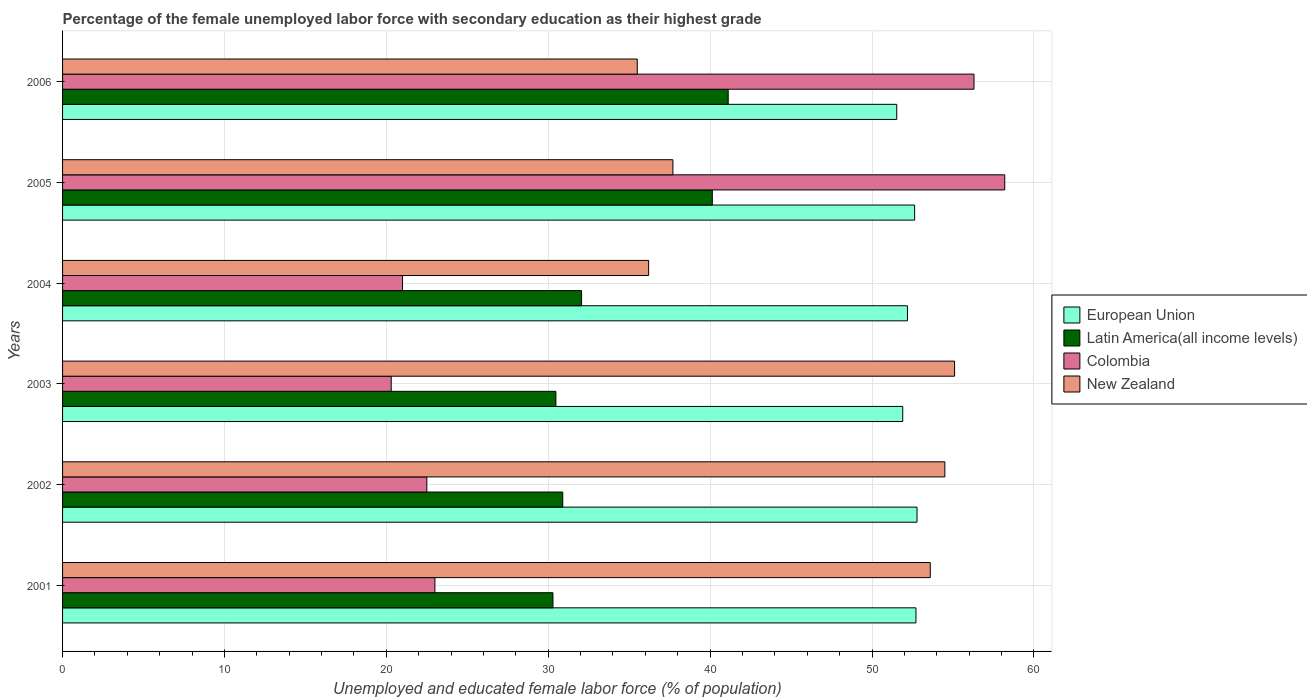How many different coloured bars are there?
Provide a succinct answer. 4. Are the number of bars on each tick of the Y-axis equal?
Your answer should be very brief. Yes. How many bars are there on the 3rd tick from the top?
Your answer should be very brief. 4. What is the label of the 5th group of bars from the top?
Keep it short and to the point. 2002. In how many cases, is the number of bars for a given year not equal to the number of legend labels?
Ensure brevity in your answer.  0. What is the percentage of the unemployed female labor force with secondary education in Colombia in 2005?
Keep it short and to the point. 58.2. Across all years, what is the maximum percentage of the unemployed female labor force with secondary education in European Union?
Your answer should be very brief. 52.78. Across all years, what is the minimum percentage of the unemployed female labor force with secondary education in Latin America(all income levels)?
Offer a terse response. 30.29. In which year was the percentage of the unemployed female labor force with secondary education in New Zealand maximum?
Provide a short and direct response. 2003. In which year was the percentage of the unemployed female labor force with secondary education in European Union minimum?
Your answer should be compact. 2006. What is the total percentage of the unemployed female labor force with secondary education in European Union in the graph?
Make the answer very short. 313.74. What is the difference between the percentage of the unemployed female labor force with secondary education in Latin America(all income levels) in 2001 and that in 2003?
Your answer should be compact. -0.18. What is the difference between the percentage of the unemployed female labor force with secondary education in Latin America(all income levels) in 2004 and the percentage of the unemployed female labor force with secondary education in New Zealand in 2001?
Provide a succinct answer. -21.54. What is the average percentage of the unemployed female labor force with secondary education in New Zealand per year?
Give a very brief answer. 45.43. In the year 2003, what is the difference between the percentage of the unemployed female labor force with secondary education in Colombia and percentage of the unemployed female labor force with secondary education in Latin America(all income levels)?
Your answer should be compact. -10.17. In how many years, is the percentage of the unemployed female labor force with secondary education in Colombia greater than 28 %?
Offer a very short reply. 2. What is the ratio of the percentage of the unemployed female labor force with secondary education in Colombia in 2003 to that in 2006?
Ensure brevity in your answer.  0.36. Is the percentage of the unemployed female labor force with secondary education in Colombia in 2002 less than that in 2006?
Your answer should be compact. Yes. What is the difference between the highest and the second highest percentage of the unemployed female labor force with secondary education in Latin America(all income levels)?
Make the answer very short. 0.98. What is the difference between the highest and the lowest percentage of the unemployed female labor force with secondary education in European Union?
Offer a terse response. 1.25. In how many years, is the percentage of the unemployed female labor force with secondary education in New Zealand greater than the average percentage of the unemployed female labor force with secondary education in New Zealand taken over all years?
Offer a terse response. 3. Is it the case that in every year, the sum of the percentage of the unemployed female labor force with secondary education in European Union and percentage of the unemployed female labor force with secondary education in New Zealand is greater than the sum of percentage of the unemployed female labor force with secondary education in Latin America(all income levels) and percentage of the unemployed female labor force with secondary education in Colombia?
Provide a succinct answer. Yes. What does the 1st bar from the top in 2004 represents?
Your answer should be compact. New Zealand. What does the 2nd bar from the bottom in 2004 represents?
Offer a very short reply. Latin America(all income levels). Is it the case that in every year, the sum of the percentage of the unemployed female labor force with secondary education in New Zealand and percentage of the unemployed female labor force with secondary education in Colombia is greater than the percentage of the unemployed female labor force with secondary education in European Union?
Your answer should be compact. Yes. How many bars are there?
Provide a succinct answer. 24. How many legend labels are there?
Offer a terse response. 4. What is the title of the graph?
Make the answer very short. Percentage of the female unemployed labor force with secondary education as their highest grade. Does "Greenland" appear as one of the legend labels in the graph?
Your answer should be compact. No. What is the label or title of the X-axis?
Offer a terse response. Unemployed and educated female labor force (% of population). What is the label or title of the Y-axis?
Keep it short and to the point. Years. What is the Unemployed and educated female labor force (% of population) in European Union in 2001?
Make the answer very short. 52.72. What is the Unemployed and educated female labor force (% of population) in Latin America(all income levels) in 2001?
Offer a very short reply. 30.29. What is the Unemployed and educated female labor force (% of population) of Colombia in 2001?
Provide a short and direct response. 23. What is the Unemployed and educated female labor force (% of population) in New Zealand in 2001?
Provide a short and direct response. 53.6. What is the Unemployed and educated female labor force (% of population) of European Union in 2002?
Give a very brief answer. 52.78. What is the Unemployed and educated female labor force (% of population) of Latin America(all income levels) in 2002?
Ensure brevity in your answer.  30.9. What is the Unemployed and educated female labor force (% of population) of New Zealand in 2002?
Give a very brief answer. 54.5. What is the Unemployed and educated female labor force (% of population) in European Union in 2003?
Keep it short and to the point. 51.9. What is the Unemployed and educated female labor force (% of population) of Latin America(all income levels) in 2003?
Offer a terse response. 30.47. What is the Unemployed and educated female labor force (% of population) in Colombia in 2003?
Give a very brief answer. 20.3. What is the Unemployed and educated female labor force (% of population) of New Zealand in 2003?
Your answer should be compact. 55.1. What is the Unemployed and educated female labor force (% of population) of European Union in 2004?
Ensure brevity in your answer.  52.19. What is the Unemployed and educated female labor force (% of population) in Latin America(all income levels) in 2004?
Your response must be concise. 32.06. What is the Unemployed and educated female labor force (% of population) of New Zealand in 2004?
Provide a succinct answer. 36.2. What is the Unemployed and educated female labor force (% of population) of European Union in 2005?
Your answer should be compact. 52.63. What is the Unemployed and educated female labor force (% of population) in Latin America(all income levels) in 2005?
Provide a short and direct response. 40.14. What is the Unemployed and educated female labor force (% of population) of Colombia in 2005?
Provide a succinct answer. 58.2. What is the Unemployed and educated female labor force (% of population) in New Zealand in 2005?
Offer a terse response. 37.7. What is the Unemployed and educated female labor force (% of population) in European Union in 2006?
Ensure brevity in your answer.  51.53. What is the Unemployed and educated female labor force (% of population) in Latin America(all income levels) in 2006?
Make the answer very short. 41.12. What is the Unemployed and educated female labor force (% of population) of Colombia in 2006?
Give a very brief answer. 56.3. What is the Unemployed and educated female labor force (% of population) of New Zealand in 2006?
Offer a very short reply. 35.5. Across all years, what is the maximum Unemployed and educated female labor force (% of population) in European Union?
Provide a succinct answer. 52.78. Across all years, what is the maximum Unemployed and educated female labor force (% of population) in Latin America(all income levels)?
Make the answer very short. 41.12. Across all years, what is the maximum Unemployed and educated female labor force (% of population) of Colombia?
Provide a succinct answer. 58.2. Across all years, what is the maximum Unemployed and educated female labor force (% of population) in New Zealand?
Offer a very short reply. 55.1. Across all years, what is the minimum Unemployed and educated female labor force (% of population) in European Union?
Make the answer very short. 51.53. Across all years, what is the minimum Unemployed and educated female labor force (% of population) of Latin America(all income levels)?
Offer a very short reply. 30.29. Across all years, what is the minimum Unemployed and educated female labor force (% of population) in Colombia?
Your answer should be very brief. 20.3. Across all years, what is the minimum Unemployed and educated female labor force (% of population) in New Zealand?
Offer a very short reply. 35.5. What is the total Unemployed and educated female labor force (% of population) of European Union in the graph?
Your response must be concise. 313.74. What is the total Unemployed and educated female labor force (% of population) of Latin America(all income levels) in the graph?
Provide a succinct answer. 204.97. What is the total Unemployed and educated female labor force (% of population) in Colombia in the graph?
Make the answer very short. 201.3. What is the total Unemployed and educated female labor force (% of population) of New Zealand in the graph?
Your response must be concise. 272.6. What is the difference between the Unemployed and educated female labor force (% of population) in European Union in 2001 and that in 2002?
Your answer should be very brief. -0.06. What is the difference between the Unemployed and educated female labor force (% of population) of Latin America(all income levels) in 2001 and that in 2002?
Give a very brief answer. -0.61. What is the difference between the Unemployed and educated female labor force (% of population) of New Zealand in 2001 and that in 2002?
Offer a very short reply. -0.9. What is the difference between the Unemployed and educated female labor force (% of population) of European Union in 2001 and that in 2003?
Make the answer very short. 0.82. What is the difference between the Unemployed and educated female labor force (% of population) of Latin America(all income levels) in 2001 and that in 2003?
Offer a very short reply. -0.18. What is the difference between the Unemployed and educated female labor force (% of population) in Colombia in 2001 and that in 2003?
Give a very brief answer. 2.7. What is the difference between the Unemployed and educated female labor force (% of population) in European Union in 2001 and that in 2004?
Provide a short and direct response. 0.53. What is the difference between the Unemployed and educated female labor force (% of population) of Latin America(all income levels) in 2001 and that in 2004?
Make the answer very short. -1.77. What is the difference between the Unemployed and educated female labor force (% of population) in Colombia in 2001 and that in 2004?
Keep it short and to the point. 2. What is the difference between the Unemployed and educated female labor force (% of population) in New Zealand in 2001 and that in 2004?
Keep it short and to the point. 17.4. What is the difference between the Unemployed and educated female labor force (% of population) in European Union in 2001 and that in 2005?
Offer a very short reply. 0.08. What is the difference between the Unemployed and educated female labor force (% of population) of Latin America(all income levels) in 2001 and that in 2005?
Your answer should be very brief. -9.85. What is the difference between the Unemployed and educated female labor force (% of population) of Colombia in 2001 and that in 2005?
Your response must be concise. -35.2. What is the difference between the Unemployed and educated female labor force (% of population) of New Zealand in 2001 and that in 2005?
Offer a terse response. 15.9. What is the difference between the Unemployed and educated female labor force (% of population) in European Union in 2001 and that in 2006?
Offer a terse response. 1.19. What is the difference between the Unemployed and educated female labor force (% of population) of Latin America(all income levels) in 2001 and that in 2006?
Offer a very short reply. -10.83. What is the difference between the Unemployed and educated female labor force (% of population) in Colombia in 2001 and that in 2006?
Provide a short and direct response. -33.3. What is the difference between the Unemployed and educated female labor force (% of population) in New Zealand in 2001 and that in 2006?
Your answer should be compact. 18.1. What is the difference between the Unemployed and educated female labor force (% of population) of European Union in 2002 and that in 2003?
Ensure brevity in your answer.  0.88. What is the difference between the Unemployed and educated female labor force (% of population) in Latin America(all income levels) in 2002 and that in 2003?
Your response must be concise. 0.42. What is the difference between the Unemployed and educated female labor force (% of population) in Colombia in 2002 and that in 2003?
Provide a short and direct response. 2.2. What is the difference between the Unemployed and educated female labor force (% of population) in European Union in 2002 and that in 2004?
Keep it short and to the point. 0.59. What is the difference between the Unemployed and educated female labor force (% of population) of Latin America(all income levels) in 2002 and that in 2004?
Provide a succinct answer. -1.16. What is the difference between the Unemployed and educated female labor force (% of population) of Colombia in 2002 and that in 2004?
Offer a terse response. 1.5. What is the difference between the Unemployed and educated female labor force (% of population) in New Zealand in 2002 and that in 2004?
Ensure brevity in your answer.  18.3. What is the difference between the Unemployed and educated female labor force (% of population) in European Union in 2002 and that in 2005?
Ensure brevity in your answer.  0.15. What is the difference between the Unemployed and educated female labor force (% of population) of Latin America(all income levels) in 2002 and that in 2005?
Make the answer very short. -9.24. What is the difference between the Unemployed and educated female labor force (% of population) in Colombia in 2002 and that in 2005?
Keep it short and to the point. -35.7. What is the difference between the Unemployed and educated female labor force (% of population) of European Union in 2002 and that in 2006?
Offer a terse response. 1.25. What is the difference between the Unemployed and educated female labor force (% of population) in Latin America(all income levels) in 2002 and that in 2006?
Offer a very short reply. -10.22. What is the difference between the Unemployed and educated female labor force (% of population) in Colombia in 2002 and that in 2006?
Ensure brevity in your answer.  -33.8. What is the difference between the Unemployed and educated female labor force (% of population) of New Zealand in 2002 and that in 2006?
Give a very brief answer. 19. What is the difference between the Unemployed and educated female labor force (% of population) of European Union in 2003 and that in 2004?
Give a very brief answer. -0.29. What is the difference between the Unemployed and educated female labor force (% of population) of Latin America(all income levels) in 2003 and that in 2004?
Give a very brief answer. -1.59. What is the difference between the Unemployed and educated female labor force (% of population) of Colombia in 2003 and that in 2004?
Provide a short and direct response. -0.7. What is the difference between the Unemployed and educated female labor force (% of population) in New Zealand in 2003 and that in 2004?
Provide a short and direct response. 18.9. What is the difference between the Unemployed and educated female labor force (% of population) in European Union in 2003 and that in 2005?
Keep it short and to the point. -0.74. What is the difference between the Unemployed and educated female labor force (% of population) in Latin America(all income levels) in 2003 and that in 2005?
Keep it short and to the point. -9.66. What is the difference between the Unemployed and educated female labor force (% of population) in Colombia in 2003 and that in 2005?
Make the answer very short. -37.9. What is the difference between the Unemployed and educated female labor force (% of population) of New Zealand in 2003 and that in 2005?
Make the answer very short. 17.4. What is the difference between the Unemployed and educated female labor force (% of population) in European Union in 2003 and that in 2006?
Your response must be concise. 0.37. What is the difference between the Unemployed and educated female labor force (% of population) of Latin America(all income levels) in 2003 and that in 2006?
Keep it short and to the point. -10.64. What is the difference between the Unemployed and educated female labor force (% of population) in Colombia in 2003 and that in 2006?
Give a very brief answer. -36. What is the difference between the Unemployed and educated female labor force (% of population) of New Zealand in 2003 and that in 2006?
Keep it short and to the point. 19.6. What is the difference between the Unemployed and educated female labor force (% of population) of European Union in 2004 and that in 2005?
Your answer should be compact. -0.44. What is the difference between the Unemployed and educated female labor force (% of population) in Latin America(all income levels) in 2004 and that in 2005?
Provide a succinct answer. -8.08. What is the difference between the Unemployed and educated female labor force (% of population) of Colombia in 2004 and that in 2005?
Offer a very short reply. -37.2. What is the difference between the Unemployed and educated female labor force (% of population) of European Union in 2004 and that in 2006?
Your response must be concise. 0.66. What is the difference between the Unemployed and educated female labor force (% of population) of Latin America(all income levels) in 2004 and that in 2006?
Offer a very short reply. -9.06. What is the difference between the Unemployed and educated female labor force (% of population) of Colombia in 2004 and that in 2006?
Ensure brevity in your answer.  -35.3. What is the difference between the Unemployed and educated female labor force (% of population) in New Zealand in 2004 and that in 2006?
Provide a short and direct response. 0.7. What is the difference between the Unemployed and educated female labor force (% of population) in European Union in 2005 and that in 2006?
Offer a terse response. 1.11. What is the difference between the Unemployed and educated female labor force (% of population) in Latin America(all income levels) in 2005 and that in 2006?
Keep it short and to the point. -0.98. What is the difference between the Unemployed and educated female labor force (% of population) in New Zealand in 2005 and that in 2006?
Keep it short and to the point. 2.2. What is the difference between the Unemployed and educated female labor force (% of population) of European Union in 2001 and the Unemployed and educated female labor force (% of population) of Latin America(all income levels) in 2002?
Provide a succinct answer. 21.82. What is the difference between the Unemployed and educated female labor force (% of population) in European Union in 2001 and the Unemployed and educated female labor force (% of population) in Colombia in 2002?
Give a very brief answer. 30.22. What is the difference between the Unemployed and educated female labor force (% of population) in European Union in 2001 and the Unemployed and educated female labor force (% of population) in New Zealand in 2002?
Keep it short and to the point. -1.78. What is the difference between the Unemployed and educated female labor force (% of population) of Latin America(all income levels) in 2001 and the Unemployed and educated female labor force (% of population) of Colombia in 2002?
Offer a very short reply. 7.79. What is the difference between the Unemployed and educated female labor force (% of population) of Latin America(all income levels) in 2001 and the Unemployed and educated female labor force (% of population) of New Zealand in 2002?
Offer a terse response. -24.21. What is the difference between the Unemployed and educated female labor force (% of population) in Colombia in 2001 and the Unemployed and educated female labor force (% of population) in New Zealand in 2002?
Make the answer very short. -31.5. What is the difference between the Unemployed and educated female labor force (% of population) of European Union in 2001 and the Unemployed and educated female labor force (% of population) of Latin America(all income levels) in 2003?
Provide a short and direct response. 22.24. What is the difference between the Unemployed and educated female labor force (% of population) of European Union in 2001 and the Unemployed and educated female labor force (% of population) of Colombia in 2003?
Your answer should be compact. 32.42. What is the difference between the Unemployed and educated female labor force (% of population) in European Union in 2001 and the Unemployed and educated female labor force (% of population) in New Zealand in 2003?
Give a very brief answer. -2.38. What is the difference between the Unemployed and educated female labor force (% of population) of Latin America(all income levels) in 2001 and the Unemployed and educated female labor force (% of population) of Colombia in 2003?
Your response must be concise. 9.99. What is the difference between the Unemployed and educated female labor force (% of population) in Latin America(all income levels) in 2001 and the Unemployed and educated female labor force (% of population) in New Zealand in 2003?
Provide a short and direct response. -24.81. What is the difference between the Unemployed and educated female labor force (% of population) in Colombia in 2001 and the Unemployed and educated female labor force (% of population) in New Zealand in 2003?
Ensure brevity in your answer.  -32.1. What is the difference between the Unemployed and educated female labor force (% of population) of European Union in 2001 and the Unemployed and educated female labor force (% of population) of Latin America(all income levels) in 2004?
Give a very brief answer. 20.66. What is the difference between the Unemployed and educated female labor force (% of population) of European Union in 2001 and the Unemployed and educated female labor force (% of population) of Colombia in 2004?
Keep it short and to the point. 31.72. What is the difference between the Unemployed and educated female labor force (% of population) of European Union in 2001 and the Unemployed and educated female labor force (% of population) of New Zealand in 2004?
Offer a very short reply. 16.52. What is the difference between the Unemployed and educated female labor force (% of population) in Latin America(all income levels) in 2001 and the Unemployed and educated female labor force (% of population) in Colombia in 2004?
Your answer should be compact. 9.29. What is the difference between the Unemployed and educated female labor force (% of population) in Latin America(all income levels) in 2001 and the Unemployed and educated female labor force (% of population) in New Zealand in 2004?
Ensure brevity in your answer.  -5.91. What is the difference between the Unemployed and educated female labor force (% of population) of European Union in 2001 and the Unemployed and educated female labor force (% of population) of Latin America(all income levels) in 2005?
Your answer should be compact. 12.58. What is the difference between the Unemployed and educated female labor force (% of population) of European Union in 2001 and the Unemployed and educated female labor force (% of population) of Colombia in 2005?
Provide a short and direct response. -5.48. What is the difference between the Unemployed and educated female labor force (% of population) of European Union in 2001 and the Unemployed and educated female labor force (% of population) of New Zealand in 2005?
Offer a very short reply. 15.02. What is the difference between the Unemployed and educated female labor force (% of population) of Latin America(all income levels) in 2001 and the Unemployed and educated female labor force (% of population) of Colombia in 2005?
Provide a short and direct response. -27.91. What is the difference between the Unemployed and educated female labor force (% of population) of Latin America(all income levels) in 2001 and the Unemployed and educated female labor force (% of population) of New Zealand in 2005?
Your response must be concise. -7.41. What is the difference between the Unemployed and educated female labor force (% of population) of Colombia in 2001 and the Unemployed and educated female labor force (% of population) of New Zealand in 2005?
Provide a short and direct response. -14.7. What is the difference between the Unemployed and educated female labor force (% of population) of European Union in 2001 and the Unemployed and educated female labor force (% of population) of Latin America(all income levels) in 2006?
Offer a terse response. 11.6. What is the difference between the Unemployed and educated female labor force (% of population) of European Union in 2001 and the Unemployed and educated female labor force (% of population) of Colombia in 2006?
Provide a short and direct response. -3.58. What is the difference between the Unemployed and educated female labor force (% of population) in European Union in 2001 and the Unemployed and educated female labor force (% of population) in New Zealand in 2006?
Keep it short and to the point. 17.22. What is the difference between the Unemployed and educated female labor force (% of population) of Latin America(all income levels) in 2001 and the Unemployed and educated female labor force (% of population) of Colombia in 2006?
Offer a terse response. -26.01. What is the difference between the Unemployed and educated female labor force (% of population) of Latin America(all income levels) in 2001 and the Unemployed and educated female labor force (% of population) of New Zealand in 2006?
Make the answer very short. -5.21. What is the difference between the Unemployed and educated female labor force (% of population) of Colombia in 2001 and the Unemployed and educated female labor force (% of population) of New Zealand in 2006?
Your response must be concise. -12.5. What is the difference between the Unemployed and educated female labor force (% of population) in European Union in 2002 and the Unemployed and educated female labor force (% of population) in Latin America(all income levels) in 2003?
Your answer should be compact. 22.31. What is the difference between the Unemployed and educated female labor force (% of population) of European Union in 2002 and the Unemployed and educated female labor force (% of population) of Colombia in 2003?
Offer a terse response. 32.48. What is the difference between the Unemployed and educated female labor force (% of population) in European Union in 2002 and the Unemployed and educated female labor force (% of population) in New Zealand in 2003?
Offer a terse response. -2.32. What is the difference between the Unemployed and educated female labor force (% of population) of Latin America(all income levels) in 2002 and the Unemployed and educated female labor force (% of population) of Colombia in 2003?
Make the answer very short. 10.6. What is the difference between the Unemployed and educated female labor force (% of population) of Latin America(all income levels) in 2002 and the Unemployed and educated female labor force (% of population) of New Zealand in 2003?
Offer a very short reply. -24.2. What is the difference between the Unemployed and educated female labor force (% of population) in Colombia in 2002 and the Unemployed and educated female labor force (% of population) in New Zealand in 2003?
Your answer should be compact. -32.6. What is the difference between the Unemployed and educated female labor force (% of population) of European Union in 2002 and the Unemployed and educated female labor force (% of population) of Latin America(all income levels) in 2004?
Offer a terse response. 20.72. What is the difference between the Unemployed and educated female labor force (% of population) in European Union in 2002 and the Unemployed and educated female labor force (% of population) in Colombia in 2004?
Your answer should be compact. 31.78. What is the difference between the Unemployed and educated female labor force (% of population) of European Union in 2002 and the Unemployed and educated female labor force (% of population) of New Zealand in 2004?
Give a very brief answer. 16.58. What is the difference between the Unemployed and educated female labor force (% of population) in Latin America(all income levels) in 2002 and the Unemployed and educated female labor force (% of population) in Colombia in 2004?
Your answer should be very brief. 9.9. What is the difference between the Unemployed and educated female labor force (% of population) in Latin America(all income levels) in 2002 and the Unemployed and educated female labor force (% of population) in New Zealand in 2004?
Your answer should be very brief. -5.3. What is the difference between the Unemployed and educated female labor force (% of population) in Colombia in 2002 and the Unemployed and educated female labor force (% of population) in New Zealand in 2004?
Your answer should be very brief. -13.7. What is the difference between the Unemployed and educated female labor force (% of population) of European Union in 2002 and the Unemployed and educated female labor force (% of population) of Latin America(all income levels) in 2005?
Your response must be concise. 12.64. What is the difference between the Unemployed and educated female labor force (% of population) of European Union in 2002 and the Unemployed and educated female labor force (% of population) of Colombia in 2005?
Your answer should be very brief. -5.42. What is the difference between the Unemployed and educated female labor force (% of population) in European Union in 2002 and the Unemployed and educated female labor force (% of population) in New Zealand in 2005?
Your answer should be compact. 15.08. What is the difference between the Unemployed and educated female labor force (% of population) in Latin America(all income levels) in 2002 and the Unemployed and educated female labor force (% of population) in Colombia in 2005?
Provide a succinct answer. -27.3. What is the difference between the Unemployed and educated female labor force (% of population) of Latin America(all income levels) in 2002 and the Unemployed and educated female labor force (% of population) of New Zealand in 2005?
Make the answer very short. -6.8. What is the difference between the Unemployed and educated female labor force (% of population) in Colombia in 2002 and the Unemployed and educated female labor force (% of population) in New Zealand in 2005?
Provide a short and direct response. -15.2. What is the difference between the Unemployed and educated female labor force (% of population) in European Union in 2002 and the Unemployed and educated female labor force (% of population) in Latin America(all income levels) in 2006?
Your response must be concise. 11.66. What is the difference between the Unemployed and educated female labor force (% of population) of European Union in 2002 and the Unemployed and educated female labor force (% of population) of Colombia in 2006?
Your answer should be compact. -3.52. What is the difference between the Unemployed and educated female labor force (% of population) of European Union in 2002 and the Unemployed and educated female labor force (% of population) of New Zealand in 2006?
Your answer should be very brief. 17.28. What is the difference between the Unemployed and educated female labor force (% of population) of Latin America(all income levels) in 2002 and the Unemployed and educated female labor force (% of population) of Colombia in 2006?
Provide a succinct answer. -25.4. What is the difference between the Unemployed and educated female labor force (% of population) of Latin America(all income levels) in 2002 and the Unemployed and educated female labor force (% of population) of New Zealand in 2006?
Your response must be concise. -4.6. What is the difference between the Unemployed and educated female labor force (% of population) in European Union in 2003 and the Unemployed and educated female labor force (% of population) in Latin America(all income levels) in 2004?
Offer a very short reply. 19.84. What is the difference between the Unemployed and educated female labor force (% of population) in European Union in 2003 and the Unemployed and educated female labor force (% of population) in Colombia in 2004?
Give a very brief answer. 30.9. What is the difference between the Unemployed and educated female labor force (% of population) in European Union in 2003 and the Unemployed and educated female labor force (% of population) in New Zealand in 2004?
Offer a very short reply. 15.7. What is the difference between the Unemployed and educated female labor force (% of population) of Latin America(all income levels) in 2003 and the Unemployed and educated female labor force (% of population) of Colombia in 2004?
Your response must be concise. 9.47. What is the difference between the Unemployed and educated female labor force (% of population) in Latin America(all income levels) in 2003 and the Unemployed and educated female labor force (% of population) in New Zealand in 2004?
Provide a short and direct response. -5.73. What is the difference between the Unemployed and educated female labor force (% of population) in Colombia in 2003 and the Unemployed and educated female labor force (% of population) in New Zealand in 2004?
Offer a terse response. -15.9. What is the difference between the Unemployed and educated female labor force (% of population) in European Union in 2003 and the Unemployed and educated female labor force (% of population) in Latin America(all income levels) in 2005?
Your answer should be compact. 11.76. What is the difference between the Unemployed and educated female labor force (% of population) in European Union in 2003 and the Unemployed and educated female labor force (% of population) in Colombia in 2005?
Offer a terse response. -6.3. What is the difference between the Unemployed and educated female labor force (% of population) of European Union in 2003 and the Unemployed and educated female labor force (% of population) of New Zealand in 2005?
Offer a terse response. 14.2. What is the difference between the Unemployed and educated female labor force (% of population) of Latin America(all income levels) in 2003 and the Unemployed and educated female labor force (% of population) of Colombia in 2005?
Keep it short and to the point. -27.73. What is the difference between the Unemployed and educated female labor force (% of population) in Latin America(all income levels) in 2003 and the Unemployed and educated female labor force (% of population) in New Zealand in 2005?
Ensure brevity in your answer.  -7.23. What is the difference between the Unemployed and educated female labor force (% of population) of Colombia in 2003 and the Unemployed and educated female labor force (% of population) of New Zealand in 2005?
Ensure brevity in your answer.  -17.4. What is the difference between the Unemployed and educated female labor force (% of population) of European Union in 2003 and the Unemployed and educated female labor force (% of population) of Latin America(all income levels) in 2006?
Ensure brevity in your answer.  10.78. What is the difference between the Unemployed and educated female labor force (% of population) of European Union in 2003 and the Unemployed and educated female labor force (% of population) of Colombia in 2006?
Keep it short and to the point. -4.4. What is the difference between the Unemployed and educated female labor force (% of population) of European Union in 2003 and the Unemployed and educated female labor force (% of population) of New Zealand in 2006?
Your answer should be very brief. 16.4. What is the difference between the Unemployed and educated female labor force (% of population) in Latin America(all income levels) in 2003 and the Unemployed and educated female labor force (% of population) in Colombia in 2006?
Offer a very short reply. -25.83. What is the difference between the Unemployed and educated female labor force (% of population) of Latin America(all income levels) in 2003 and the Unemployed and educated female labor force (% of population) of New Zealand in 2006?
Keep it short and to the point. -5.03. What is the difference between the Unemployed and educated female labor force (% of population) in Colombia in 2003 and the Unemployed and educated female labor force (% of population) in New Zealand in 2006?
Offer a very short reply. -15.2. What is the difference between the Unemployed and educated female labor force (% of population) of European Union in 2004 and the Unemployed and educated female labor force (% of population) of Latin America(all income levels) in 2005?
Provide a short and direct response. 12.05. What is the difference between the Unemployed and educated female labor force (% of population) of European Union in 2004 and the Unemployed and educated female labor force (% of population) of Colombia in 2005?
Make the answer very short. -6.01. What is the difference between the Unemployed and educated female labor force (% of population) in European Union in 2004 and the Unemployed and educated female labor force (% of population) in New Zealand in 2005?
Give a very brief answer. 14.49. What is the difference between the Unemployed and educated female labor force (% of population) of Latin America(all income levels) in 2004 and the Unemployed and educated female labor force (% of population) of Colombia in 2005?
Offer a terse response. -26.14. What is the difference between the Unemployed and educated female labor force (% of population) in Latin America(all income levels) in 2004 and the Unemployed and educated female labor force (% of population) in New Zealand in 2005?
Your answer should be very brief. -5.64. What is the difference between the Unemployed and educated female labor force (% of population) of Colombia in 2004 and the Unemployed and educated female labor force (% of population) of New Zealand in 2005?
Your answer should be very brief. -16.7. What is the difference between the Unemployed and educated female labor force (% of population) of European Union in 2004 and the Unemployed and educated female labor force (% of population) of Latin America(all income levels) in 2006?
Offer a terse response. 11.07. What is the difference between the Unemployed and educated female labor force (% of population) in European Union in 2004 and the Unemployed and educated female labor force (% of population) in Colombia in 2006?
Give a very brief answer. -4.11. What is the difference between the Unemployed and educated female labor force (% of population) in European Union in 2004 and the Unemployed and educated female labor force (% of population) in New Zealand in 2006?
Ensure brevity in your answer.  16.69. What is the difference between the Unemployed and educated female labor force (% of population) in Latin America(all income levels) in 2004 and the Unemployed and educated female labor force (% of population) in Colombia in 2006?
Provide a short and direct response. -24.24. What is the difference between the Unemployed and educated female labor force (% of population) of Latin America(all income levels) in 2004 and the Unemployed and educated female labor force (% of population) of New Zealand in 2006?
Your answer should be very brief. -3.44. What is the difference between the Unemployed and educated female labor force (% of population) in European Union in 2005 and the Unemployed and educated female labor force (% of population) in Latin America(all income levels) in 2006?
Offer a very short reply. 11.52. What is the difference between the Unemployed and educated female labor force (% of population) of European Union in 2005 and the Unemployed and educated female labor force (% of population) of Colombia in 2006?
Your answer should be compact. -3.67. What is the difference between the Unemployed and educated female labor force (% of population) in European Union in 2005 and the Unemployed and educated female labor force (% of population) in New Zealand in 2006?
Offer a terse response. 17.13. What is the difference between the Unemployed and educated female labor force (% of population) of Latin America(all income levels) in 2005 and the Unemployed and educated female labor force (% of population) of Colombia in 2006?
Your answer should be compact. -16.16. What is the difference between the Unemployed and educated female labor force (% of population) of Latin America(all income levels) in 2005 and the Unemployed and educated female labor force (% of population) of New Zealand in 2006?
Your answer should be compact. 4.64. What is the difference between the Unemployed and educated female labor force (% of population) of Colombia in 2005 and the Unemployed and educated female labor force (% of population) of New Zealand in 2006?
Offer a terse response. 22.7. What is the average Unemployed and educated female labor force (% of population) in European Union per year?
Ensure brevity in your answer.  52.29. What is the average Unemployed and educated female labor force (% of population) in Latin America(all income levels) per year?
Give a very brief answer. 34.16. What is the average Unemployed and educated female labor force (% of population) of Colombia per year?
Offer a very short reply. 33.55. What is the average Unemployed and educated female labor force (% of population) in New Zealand per year?
Offer a terse response. 45.43. In the year 2001, what is the difference between the Unemployed and educated female labor force (% of population) in European Union and Unemployed and educated female labor force (% of population) in Latin America(all income levels)?
Offer a terse response. 22.42. In the year 2001, what is the difference between the Unemployed and educated female labor force (% of population) in European Union and Unemployed and educated female labor force (% of population) in Colombia?
Make the answer very short. 29.72. In the year 2001, what is the difference between the Unemployed and educated female labor force (% of population) in European Union and Unemployed and educated female labor force (% of population) in New Zealand?
Provide a short and direct response. -0.88. In the year 2001, what is the difference between the Unemployed and educated female labor force (% of population) of Latin America(all income levels) and Unemployed and educated female labor force (% of population) of Colombia?
Keep it short and to the point. 7.29. In the year 2001, what is the difference between the Unemployed and educated female labor force (% of population) of Latin America(all income levels) and Unemployed and educated female labor force (% of population) of New Zealand?
Provide a short and direct response. -23.31. In the year 2001, what is the difference between the Unemployed and educated female labor force (% of population) in Colombia and Unemployed and educated female labor force (% of population) in New Zealand?
Offer a terse response. -30.6. In the year 2002, what is the difference between the Unemployed and educated female labor force (% of population) in European Union and Unemployed and educated female labor force (% of population) in Latin America(all income levels)?
Make the answer very short. 21.88. In the year 2002, what is the difference between the Unemployed and educated female labor force (% of population) of European Union and Unemployed and educated female labor force (% of population) of Colombia?
Offer a very short reply. 30.28. In the year 2002, what is the difference between the Unemployed and educated female labor force (% of population) of European Union and Unemployed and educated female labor force (% of population) of New Zealand?
Offer a terse response. -1.72. In the year 2002, what is the difference between the Unemployed and educated female labor force (% of population) in Latin America(all income levels) and Unemployed and educated female labor force (% of population) in Colombia?
Give a very brief answer. 8.4. In the year 2002, what is the difference between the Unemployed and educated female labor force (% of population) of Latin America(all income levels) and Unemployed and educated female labor force (% of population) of New Zealand?
Your answer should be very brief. -23.6. In the year 2002, what is the difference between the Unemployed and educated female labor force (% of population) of Colombia and Unemployed and educated female labor force (% of population) of New Zealand?
Offer a terse response. -32. In the year 2003, what is the difference between the Unemployed and educated female labor force (% of population) of European Union and Unemployed and educated female labor force (% of population) of Latin America(all income levels)?
Ensure brevity in your answer.  21.42. In the year 2003, what is the difference between the Unemployed and educated female labor force (% of population) of European Union and Unemployed and educated female labor force (% of population) of Colombia?
Keep it short and to the point. 31.6. In the year 2003, what is the difference between the Unemployed and educated female labor force (% of population) of European Union and Unemployed and educated female labor force (% of population) of New Zealand?
Your answer should be very brief. -3.2. In the year 2003, what is the difference between the Unemployed and educated female labor force (% of population) of Latin America(all income levels) and Unemployed and educated female labor force (% of population) of Colombia?
Give a very brief answer. 10.17. In the year 2003, what is the difference between the Unemployed and educated female labor force (% of population) in Latin America(all income levels) and Unemployed and educated female labor force (% of population) in New Zealand?
Offer a very short reply. -24.63. In the year 2003, what is the difference between the Unemployed and educated female labor force (% of population) of Colombia and Unemployed and educated female labor force (% of population) of New Zealand?
Provide a succinct answer. -34.8. In the year 2004, what is the difference between the Unemployed and educated female labor force (% of population) of European Union and Unemployed and educated female labor force (% of population) of Latin America(all income levels)?
Offer a terse response. 20.13. In the year 2004, what is the difference between the Unemployed and educated female labor force (% of population) of European Union and Unemployed and educated female labor force (% of population) of Colombia?
Your answer should be very brief. 31.19. In the year 2004, what is the difference between the Unemployed and educated female labor force (% of population) of European Union and Unemployed and educated female labor force (% of population) of New Zealand?
Make the answer very short. 15.99. In the year 2004, what is the difference between the Unemployed and educated female labor force (% of population) in Latin America(all income levels) and Unemployed and educated female labor force (% of population) in Colombia?
Keep it short and to the point. 11.06. In the year 2004, what is the difference between the Unemployed and educated female labor force (% of population) in Latin America(all income levels) and Unemployed and educated female labor force (% of population) in New Zealand?
Provide a short and direct response. -4.14. In the year 2004, what is the difference between the Unemployed and educated female labor force (% of population) in Colombia and Unemployed and educated female labor force (% of population) in New Zealand?
Your response must be concise. -15.2. In the year 2005, what is the difference between the Unemployed and educated female labor force (% of population) of European Union and Unemployed and educated female labor force (% of population) of Latin America(all income levels)?
Provide a succinct answer. 12.5. In the year 2005, what is the difference between the Unemployed and educated female labor force (% of population) in European Union and Unemployed and educated female labor force (% of population) in Colombia?
Provide a succinct answer. -5.57. In the year 2005, what is the difference between the Unemployed and educated female labor force (% of population) of European Union and Unemployed and educated female labor force (% of population) of New Zealand?
Make the answer very short. 14.93. In the year 2005, what is the difference between the Unemployed and educated female labor force (% of population) in Latin America(all income levels) and Unemployed and educated female labor force (% of population) in Colombia?
Provide a short and direct response. -18.06. In the year 2005, what is the difference between the Unemployed and educated female labor force (% of population) in Latin America(all income levels) and Unemployed and educated female labor force (% of population) in New Zealand?
Provide a succinct answer. 2.44. In the year 2005, what is the difference between the Unemployed and educated female labor force (% of population) of Colombia and Unemployed and educated female labor force (% of population) of New Zealand?
Provide a short and direct response. 20.5. In the year 2006, what is the difference between the Unemployed and educated female labor force (% of population) in European Union and Unemployed and educated female labor force (% of population) in Latin America(all income levels)?
Offer a terse response. 10.41. In the year 2006, what is the difference between the Unemployed and educated female labor force (% of population) of European Union and Unemployed and educated female labor force (% of population) of Colombia?
Your response must be concise. -4.77. In the year 2006, what is the difference between the Unemployed and educated female labor force (% of population) in European Union and Unemployed and educated female labor force (% of population) in New Zealand?
Keep it short and to the point. 16.03. In the year 2006, what is the difference between the Unemployed and educated female labor force (% of population) of Latin America(all income levels) and Unemployed and educated female labor force (% of population) of Colombia?
Give a very brief answer. -15.18. In the year 2006, what is the difference between the Unemployed and educated female labor force (% of population) in Latin America(all income levels) and Unemployed and educated female labor force (% of population) in New Zealand?
Your response must be concise. 5.62. In the year 2006, what is the difference between the Unemployed and educated female labor force (% of population) of Colombia and Unemployed and educated female labor force (% of population) of New Zealand?
Give a very brief answer. 20.8. What is the ratio of the Unemployed and educated female labor force (% of population) of European Union in 2001 to that in 2002?
Ensure brevity in your answer.  1. What is the ratio of the Unemployed and educated female labor force (% of population) of Latin America(all income levels) in 2001 to that in 2002?
Ensure brevity in your answer.  0.98. What is the ratio of the Unemployed and educated female labor force (% of population) of Colombia in 2001 to that in 2002?
Provide a short and direct response. 1.02. What is the ratio of the Unemployed and educated female labor force (% of population) of New Zealand in 2001 to that in 2002?
Ensure brevity in your answer.  0.98. What is the ratio of the Unemployed and educated female labor force (% of population) of European Union in 2001 to that in 2003?
Ensure brevity in your answer.  1.02. What is the ratio of the Unemployed and educated female labor force (% of population) in Colombia in 2001 to that in 2003?
Your answer should be very brief. 1.13. What is the ratio of the Unemployed and educated female labor force (% of population) of New Zealand in 2001 to that in 2003?
Your response must be concise. 0.97. What is the ratio of the Unemployed and educated female labor force (% of population) of European Union in 2001 to that in 2004?
Keep it short and to the point. 1.01. What is the ratio of the Unemployed and educated female labor force (% of population) in Latin America(all income levels) in 2001 to that in 2004?
Your response must be concise. 0.94. What is the ratio of the Unemployed and educated female labor force (% of population) in Colombia in 2001 to that in 2004?
Make the answer very short. 1.1. What is the ratio of the Unemployed and educated female labor force (% of population) in New Zealand in 2001 to that in 2004?
Offer a very short reply. 1.48. What is the ratio of the Unemployed and educated female labor force (% of population) of European Union in 2001 to that in 2005?
Ensure brevity in your answer.  1. What is the ratio of the Unemployed and educated female labor force (% of population) in Latin America(all income levels) in 2001 to that in 2005?
Provide a short and direct response. 0.75. What is the ratio of the Unemployed and educated female labor force (% of population) of Colombia in 2001 to that in 2005?
Offer a terse response. 0.4. What is the ratio of the Unemployed and educated female labor force (% of population) of New Zealand in 2001 to that in 2005?
Keep it short and to the point. 1.42. What is the ratio of the Unemployed and educated female labor force (% of population) in European Union in 2001 to that in 2006?
Provide a short and direct response. 1.02. What is the ratio of the Unemployed and educated female labor force (% of population) in Latin America(all income levels) in 2001 to that in 2006?
Provide a succinct answer. 0.74. What is the ratio of the Unemployed and educated female labor force (% of population) of Colombia in 2001 to that in 2006?
Provide a short and direct response. 0.41. What is the ratio of the Unemployed and educated female labor force (% of population) in New Zealand in 2001 to that in 2006?
Keep it short and to the point. 1.51. What is the ratio of the Unemployed and educated female labor force (% of population) in Latin America(all income levels) in 2002 to that in 2003?
Give a very brief answer. 1.01. What is the ratio of the Unemployed and educated female labor force (% of population) in Colombia in 2002 to that in 2003?
Give a very brief answer. 1.11. What is the ratio of the Unemployed and educated female labor force (% of population) of New Zealand in 2002 to that in 2003?
Keep it short and to the point. 0.99. What is the ratio of the Unemployed and educated female labor force (% of population) of European Union in 2002 to that in 2004?
Give a very brief answer. 1.01. What is the ratio of the Unemployed and educated female labor force (% of population) in Latin America(all income levels) in 2002 to that in 2004?
Your response must be concise. 0.96. What is the ratio of the Unemployed and educated female labor force (% of population) of Colombia in 2002 to that in 2004?
Offer a terse response. 1.07. What is the ratio of the Unemployed and educated female labor force (% of population) in New Zealand in 2002 to that in 2004?
Ensure brevity in your answer.  1.51. What is the ratio of the Unemployed and educated female labor force (% of population) of Latin America(all income levels) in 2002 to that in 2005?
Offer a terse response. 0.77. What is the ratio of the Unemployed and educated female labor force (% of population) in Colombia in 2002 to that in 2005?
Your answer should be compact. 0.39. What is the ratio of the Unemployed and educated female labor force (% of population) of New Zealand in 2002 to that in 2005?
Provide a short and direct response. 1.45. What is the ratio of the Unemployed and educated female labor force (% of population) of European Union in 2002 to that in 2006?
Your answer should be very brief. 1.02. What is the ratio of the Unemployed and educated female labor force (% of population) in Latin America(all income levels) in 2002 to that in 2006?
Your answer should be very brief. 0.75. What is the ratio of the Unemployed and educated female labor force (% of population) of Colombia in 2002 to that in 2006?
Offer a terse response. 0.4. What is the ratio of the Unemployed and educated female labor force (% of population) in New Zealand in 2002 to that in 2006?
Offer a terse response. 1.54. What is the ratio of the Unemployed and educated female labor force (% of population) in Latin America(all income levels) in 2003 to that in 2004?
Give a very brief answer. 0.95. What is the ratio of the Unemployed and educated female labor force (% of population) of Colombia in 2003 to that in 2004?
Your answer should be compact. 0.97. What is the ratio of the Unemployed and educated female labor force (% of population) in New Zealand in 2003 to that in 2004?
Provide a succinct answer. 1.52. What is the ratio of the Unemployed and educated female labor force (% of population) in European Union in 2003 to that in 2005?
Ensure brevity in your answer.  0.99. What is the ratio of the Unemployed and educated female labor force (% of population) of Latin America(all income levels) in 2003 to that in 2005?
Offer a terse response. 0.76. What is the ratio of the Unemployed and educated female labor force (% of population) in Colombia in 2003 to that in 2005?
Make the answer very short. 0.35. What is the ratio of the Unemployed and educated female labor force (% of population) in New Zealand in 2003 to that in 2005?
Offer a terse response. 1.46. What is the ratio of the Unemployed and educated female labor force (% of population) of Latin America(all income levels) in 2003 to that in 2006?
Provide a short and direct response. 0.74. What is the ratio of the Unemployed and educated female labor force (% of population) in Colombia in 2003 to that in 2006?
Offer a very short reply. 0.36. What is the ratio of the Unemployed and educated female labor force (% of population) in New Zealand in 2003 to that in 2006?
Offer a very short reply. 1.55. What is the ratio of the Unemployed and educated female labor force (% of population) in European Union in 2004 to that in 2005?
Offer a very short reply. 0.99. What is the ratio of the Unemployed and educated female labor force (% of population) of Latin America(all income levels) in 2004 to that in 2005?
Give a very brief answer. 0.8. What is the ratio of the Unemployed and educated female labor force (% of population) in Colombia in 2004 to that in 2005?
Offer a terse response. 0.36. What is the ratio of the Unemployed and educated female labor force (% of population) in New Zealand in 2004 to that in 2005?
Offer a terse response. 0.96. What is the ratio of the Unemployed and educated female labor force (% of population) of European Union in 2004 to that in 2006?
Offer a very short reply. 1.01. What is the ratio of the Unemployed and educated female labor force (% of population) of Latin America(all income levels) in 2004 to that in 2006?
Your answer should be compact. 0.78. What is the ratio of the Unemployed and educated female labor force (% of population) of Colombia in 2004 to that in 2006?
Offer a terse response. 0.37. What is the ratio of the Unemployed and educated female labor force (% of population) in New Zealand in 2004 to that in 2006?
Give a very brief answer. 1.02. What is the ratio of the Unemployed and educated female labor force (% of population) in European Union in 2005 to that in 2006?
Make the answer very short. 1.02. What is the ratio of the Unemployed and educated female labor force (% of population) of Latin America(all income levels) in 2005 to that in 2006?
Ensure brevity in your answer.  0.98. What is the ratio of the Unemployed and educated female labor force (% of population) of Colombia in 2005 to that in 2006?
Provide a short and direct response. 1.03. What is the ratio of the Unemployed and educated female labor force (% of population) of New Zealand in 2005 to that in 2006?
Your response must be concise. 1.06. What is the difference between the highest and the second highest Unemployed and educated female labor force (% of population) of European Union?
Keep it short and to the point. 0.06. What is the difference between the highest and the second highest Unemployed and educated female labor force (% of population) in Latin America(all income levels)?
Offer a terse response. 0.98. What is the difference between the highest and the second highest Unemployed and educated female labor force (% of population) in Colombia?
Provide a succinct answer. 1.9. What is the difference between the highest and the second highest Unemployed and educated female labor force (% of population) in New Zealand?
Ensure brevity in your answer.  0.6. What is the difference between the highest and the lowest Unemployed and educated female labor force (% of population) of European Union?
Your answer should be very brief. 1.25. What is the difference between the highest and the lowest Unemployed and educated female labor force (% of population) in Latin America(all income levels)?
Give a very brief answer. 10.83. What is the difference between the highest and the lowest Unemployed and educated female labor force (% of population) in Colombia?
Offer a terse response. 37.9. What is the difference between the highest and the lowest Unemployed and educated female labor force (% of population) in New Zealand?
Offer a very short reply. 19.6. 